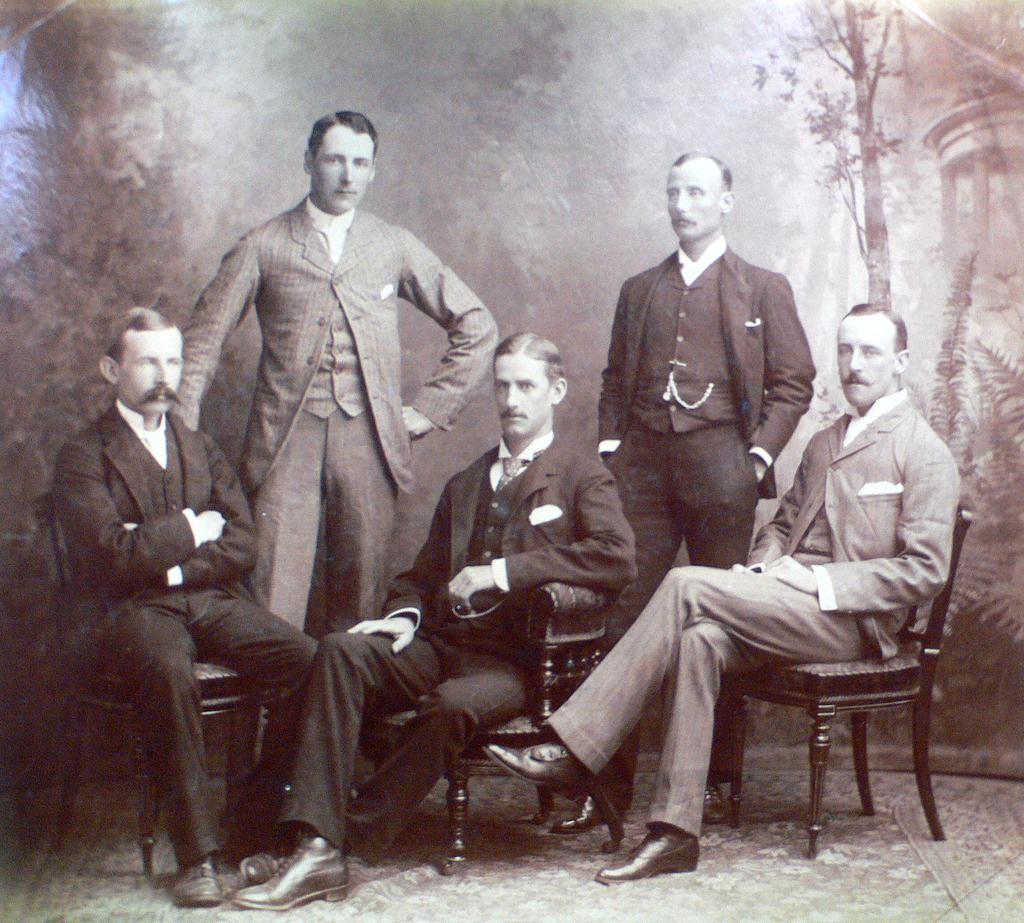How many people are present in the image? There are five men in the image. What positions are the men in? Three of the men are sitting in chairs, and two of the men are standing. What color is the sun in the image? There is no sun present in the image. What type of nose does the base have in the image? There is no base or nose present in the image. 